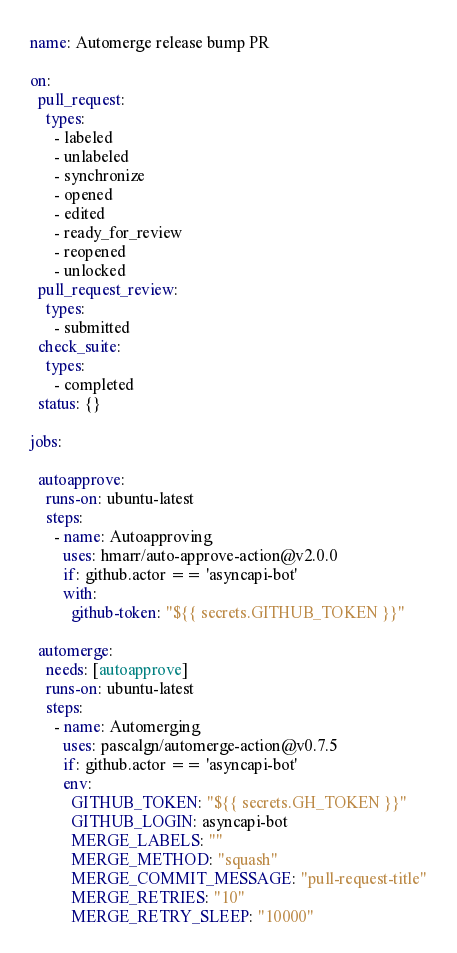<code> <loc_0><loc_0><loc_500><loc_500><_YAML_>name: Automerge release bump PR

on:
  pull_request:
    types:
      - labeled
      - unlabeled
      - synchronize
      - opened
      - edited
      - ready_for_review
      - reopened
      - unlocked
  pull_request_review:
    types:
      - submitted
  check_suite: 
    types:
      - completed
  status: {}
  
jobs:

  autoapprove:
    runs-on: ubuntu-latest
    steps:
      - name: Autoapproving
        uses: hmarr/auto-approve-action@v2.0.0
        if: github.actor == 'asyncapi-bot'
        with:
          github-token: "${{ secrets.GITHUB_TOKEN }}"

  automerge:
    needs: [autoapprove]
    runs-on: ubuntu-latest
    steps:
      - name: Automerging
        uses: pascalgn/automerge-action@v0.7.5
        if: github.actor == 'asyncapi-bot'
        env:
          GITHUB_TOKEN: "${{ secrets.GH_TOKEN }}"
          GITHUB_LOGIN: asyncapi-bot
          MERGE_LABELS: ""
          MERGE_METHOD: "squash"
          MERGE_COMMIT_MESSAGE: "pull-request-title"
          MERGE_RETRIES: "10"
          MERGE_RETRY_SLEEP: "10000"</code> 